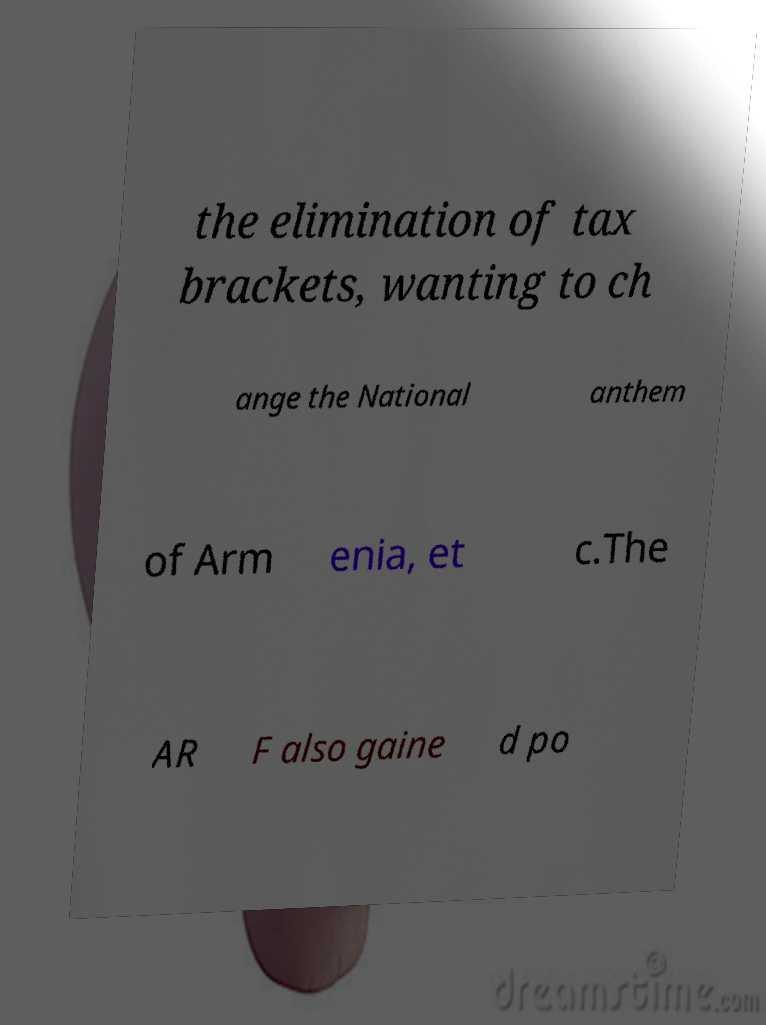Could you assist in decoding the text presented in this image and type it out clearly? the elimination of tax brackets, wanting to ch ange the National anthem of Arm enia, et c.The AR F also gaine d po 